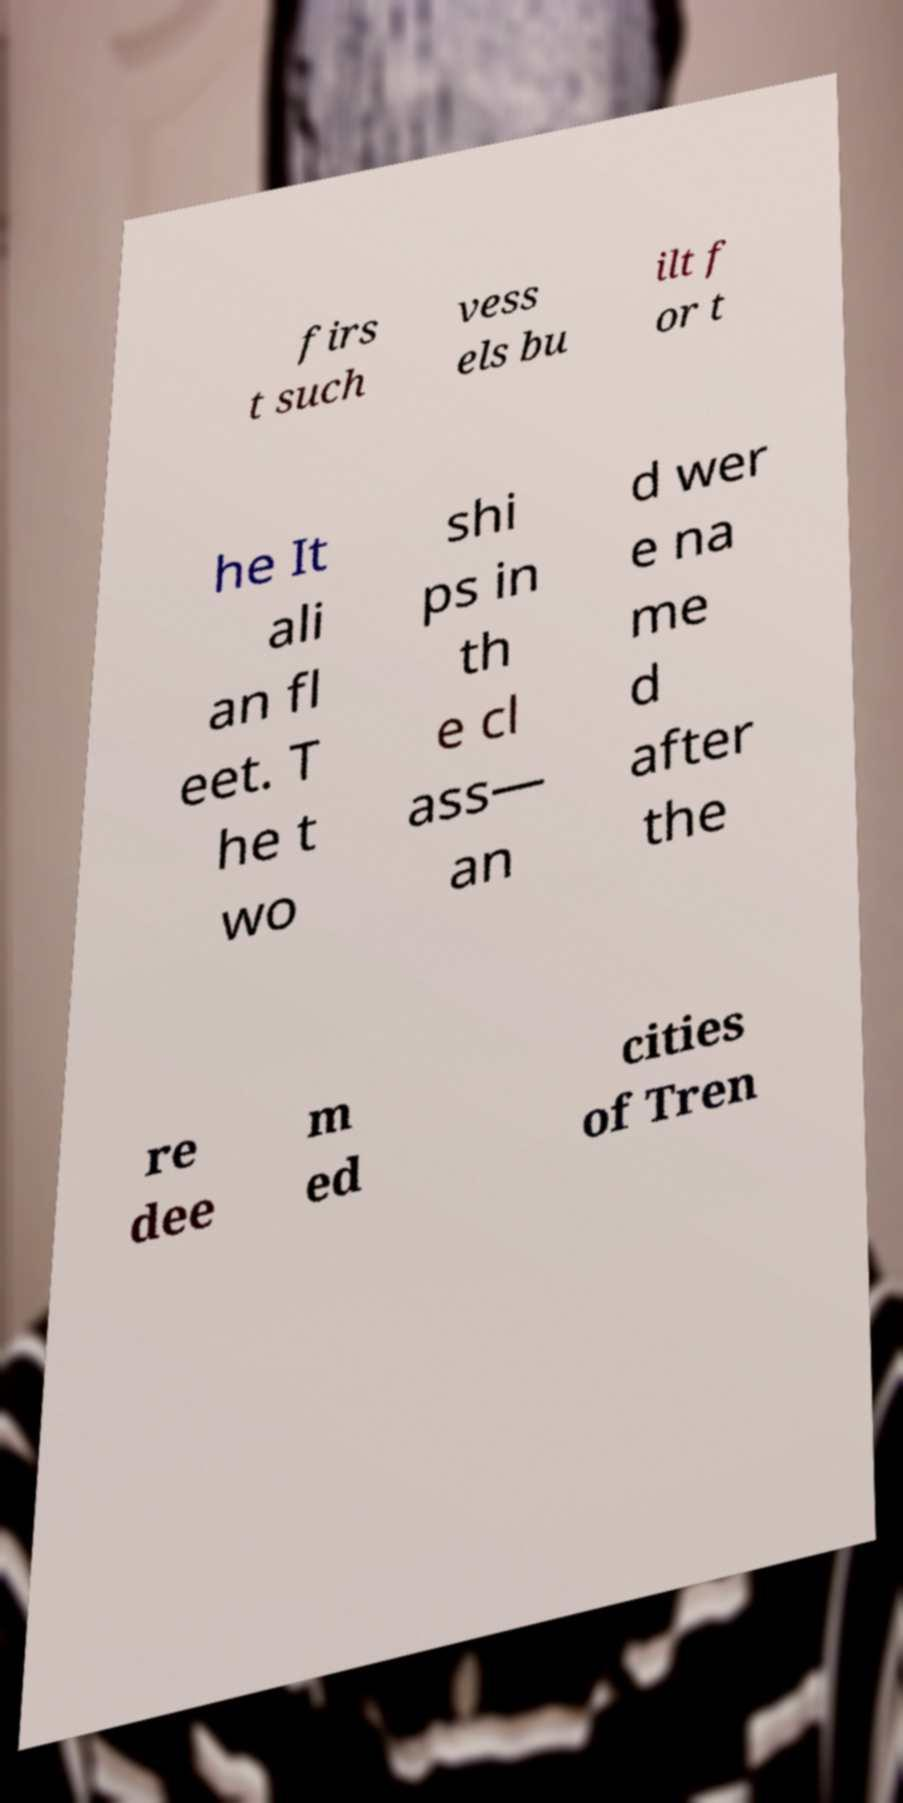There's text embedded in this image that I need extracted. Can you transcribe it verbatim? firs t such vess els bu ilt f or t he It ali an fl eet. T he t wo shi ps in th e cl ass— an d wer e na me d after the re dee m ed cities of Tren 